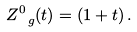<formula> <loc_0><loc_0><loc_500><loc_500>Z ^ { 0 } _ { \ g } ( t ) = ( 1 + t ) \, .</formula> 